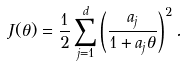<formula> <loc_0><loc_0><loc_500><loc_500>J ( \theta ) = \frac { 1 } { 2 } \sum _ { j = 1 } ^ { d } \left ( \frac { a _ { j } } { 1 + a _ { j } \theta } \right ) ^ { 2 } .</formula> 